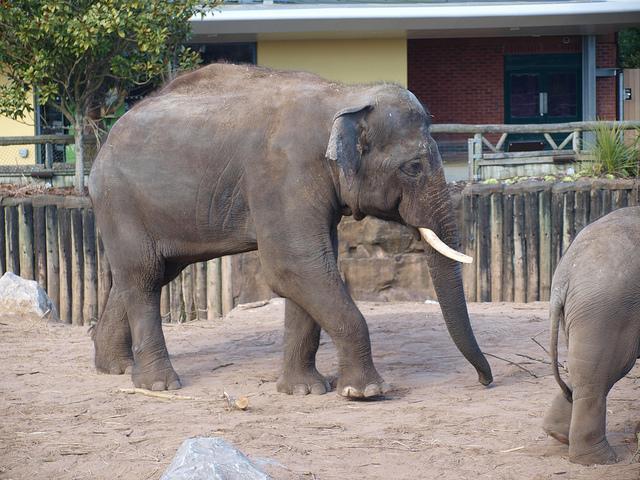How many elephants are in the photo?
Give a very brief answer. 2. 